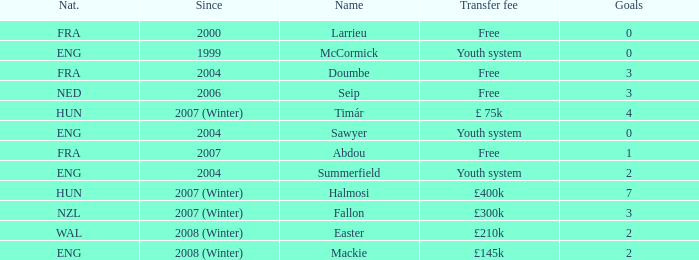What is the mean number of goals sawyer scores? 0.0. 